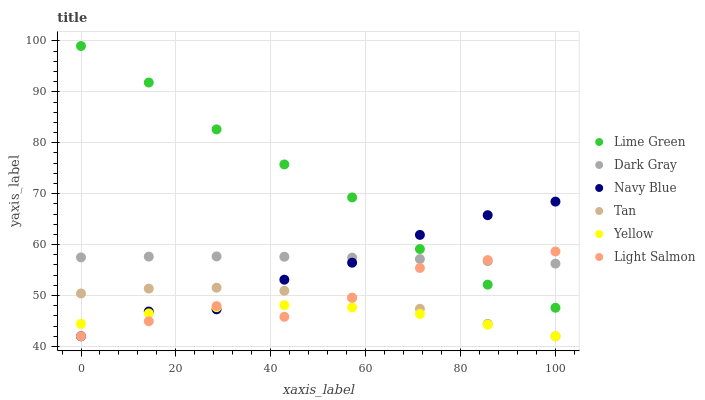Does Yellow have the minimum area under the curve?
Answer yes or no. Yes. Does Lime Green have the maximum area under the curve?
Answer yes or no. Yes. Does Navy Blue have the minimum area under the curve?
Answer yes or no. No. Does Navy Blue have the maximum area under the curve?
Answer yes or no. No. Is Dark Gray the smoothest?
Answer yes or no. Yes. Is Light Salmon the roughest?
Answer yes or no. Yes. Is Navy Blue the smoothest?
Answer yes or no. No. Is Navy Blue the roughest?
Answer yes or no. No. Does Light Salmon have the lowest value?
Answer yes or no. Yes. Does Dark Gray have the lowest value?
Answer yes or no. No. Does Lime Green have the highest value?
Answer yes or no. Yes. Does Navy Blue have the highest value?
Answer yes or no. No. Is Tan less than Dark Gray?
Answer yes or no. Yes. Is Lime Green greater than Yellow?
Answer yes or no. Yes. Does Navy Blue intersect Lime Green?
Answer yes or no. Yes. Is Navy Blue less than Lime Green?
Answer yes or no. No. Is Navy Blue greater than Lime Green?
Answer yes or no. No. Does Tan intersect Dark Gray?
Answer yes or no. No. 